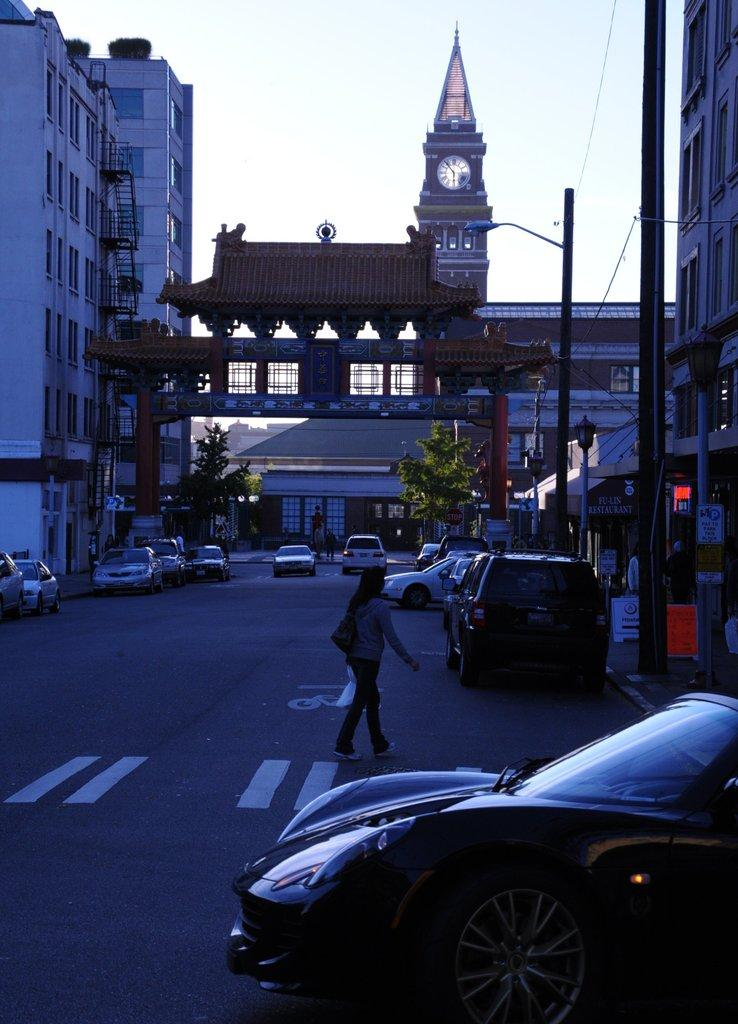What is happening on the road in the image? There are vehicles on the road in the image. What is the person in the image doing? A person is walking in the image. What can be seen in the background of the image? There are buildings, trees, electric poles, and street lights visible in the background of the image. What specific structure is present in the image? There is a clock tower in the image. Can you see any twigs or beans in the image? No, there are no twigs or beans present in the image. What type of lunch is being served in the image? There is no lunch being served in the image; it features vehicles on the road, a person walking, and various background elements. 